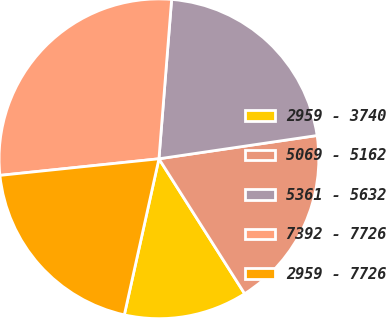Convert chart to OTSL. <chart><loc_0><loc_0><loc_500><loc_500><pie_chart><fcel>2959 - 3740<fcel>5069 - 5162<fcel>5361 - 5632<fcel>7392 - 7726<fcel>2959 - 7726<nl><fcel>12.48%<fcel>18.32%<fcel>21.41%<fcel>27.92%<fcel>19.87%<nl></chart> 